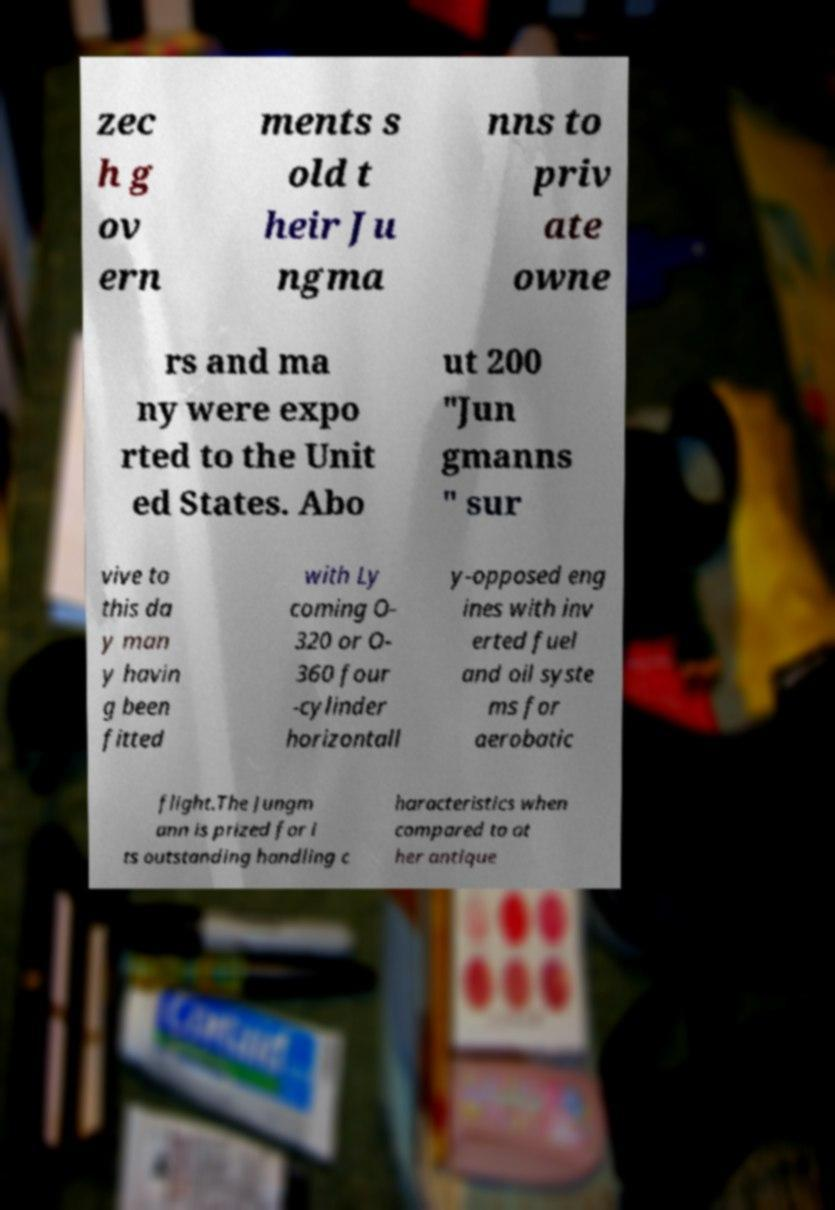Could you assist in decoding the text presented in this image and type it out clearly? zec h g ov ern ments s old t heir Ju ngma nns to priv ate owne rs and ma ny were expo rted to the Unit ed States. Abo ut 200 "Jun gmanns " sur vive to this da y man y havin g been fitted with Ly coming O- 320 or O- 360 four -cylinder horizontall y-opposed eng ines with inv erted fuel and oil syste ms for aerobatic flight.The Jungm ann is prized for i ts outstanding handling c haracteristics when compared to ot her antique 